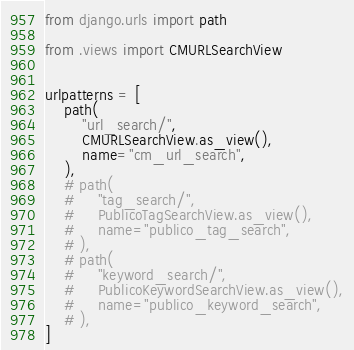<code> <loc_0><loc_0><loc_500><loc_500><_Python_>from django.urls import path

from .views import CMURLSearchView


urlpatterns = [
    path(
        "url_search/",
        CMURLSearchView.as_view(),
        name="cm_url_search",
    ),
    # path(
    #     "tag_search/",
    #     PublicoTagSearchView.as_view(),
    #     name="publico_tag_search",
    # ),
    # path(
    #     "keyword_search/",
    #     PublicoKeywordSearchView.as_view(),
    #     name="publico_keyword_search",
    # ),
]
</code> 